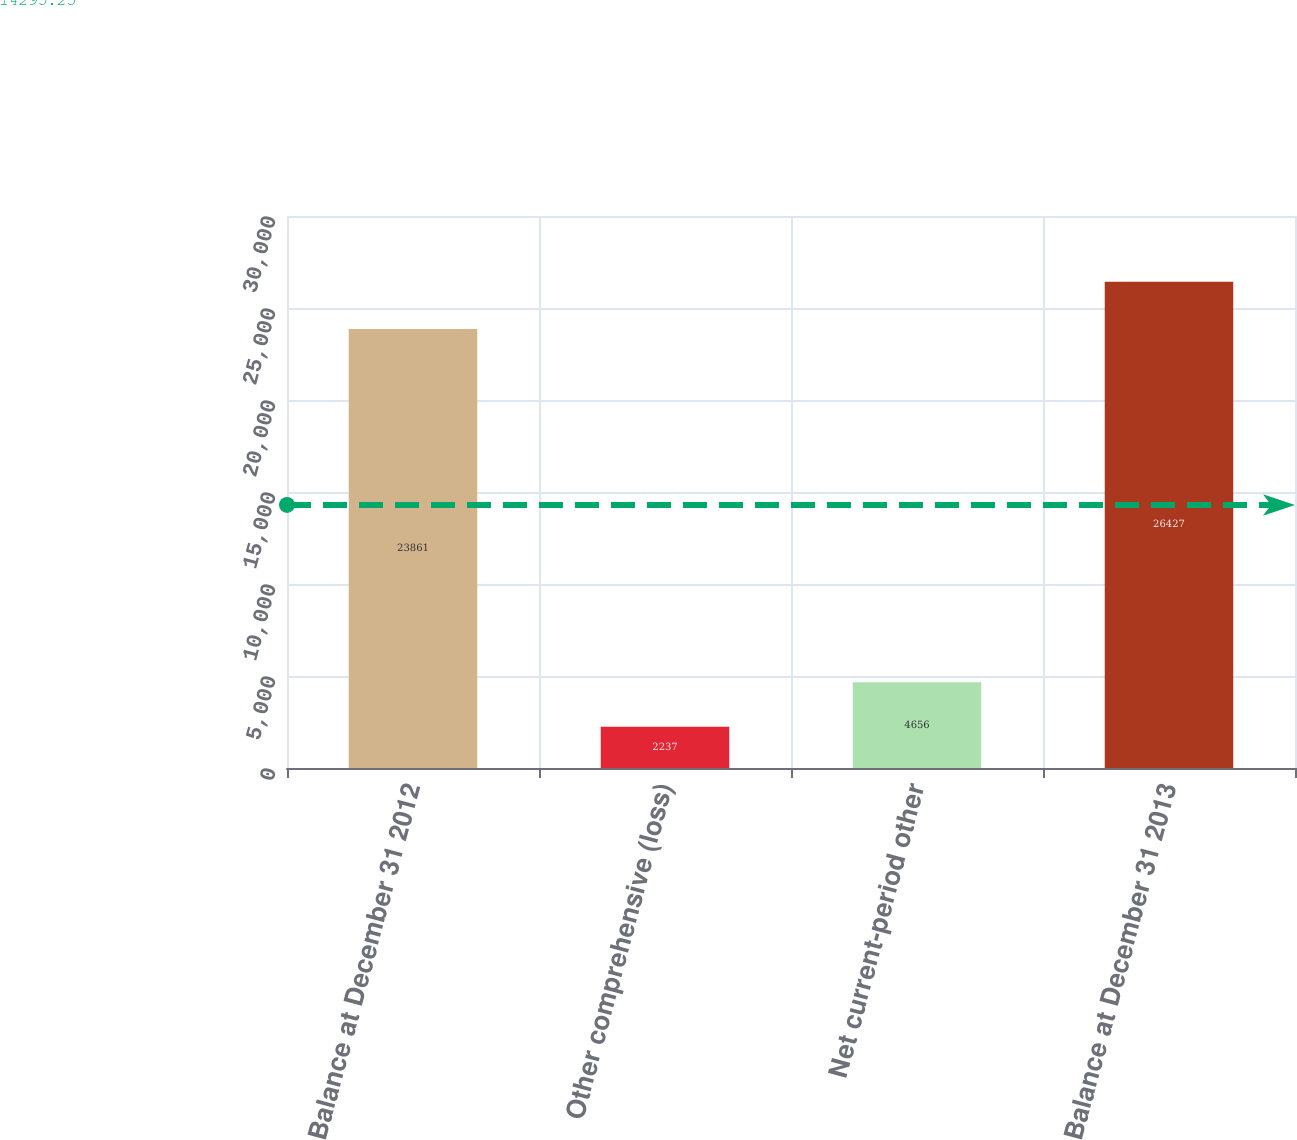<chart> <loc_0><loc_0><loc_500><loc_500><bar_chart><fcel>Balance at December 31 2012<fcel>Other comprehensive (loss)<fcel>Net current-period other<fcel>Balance at December 31 2013<nl><fcel>23861<fcel>2237<fcel>4656<fcel>26427<nl></chart> 